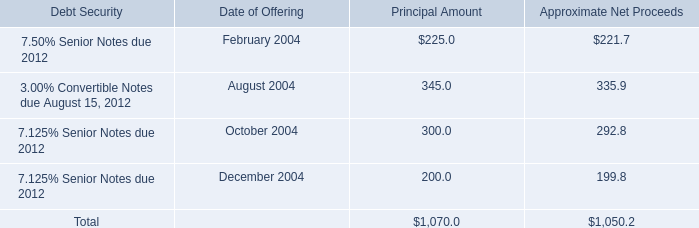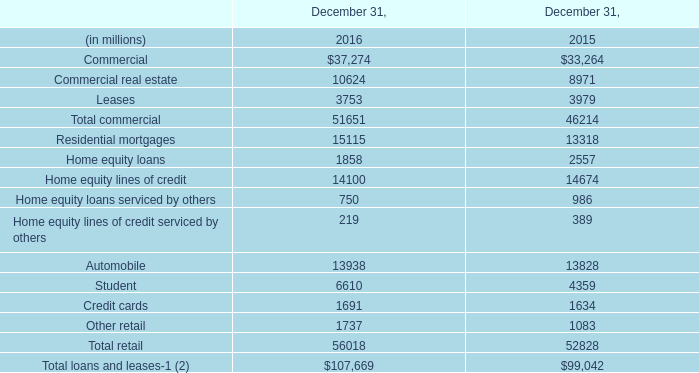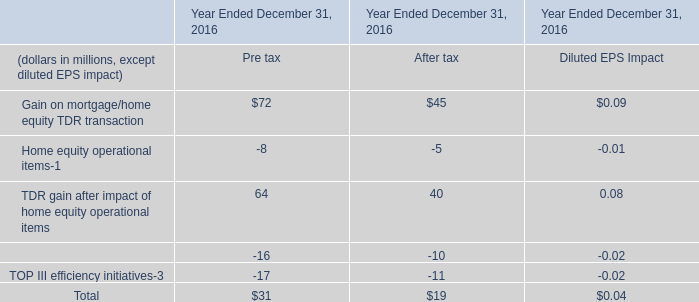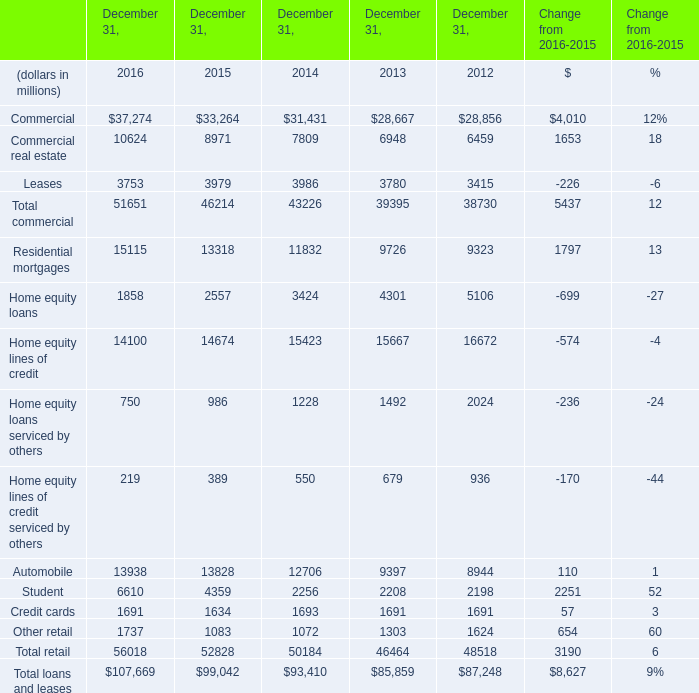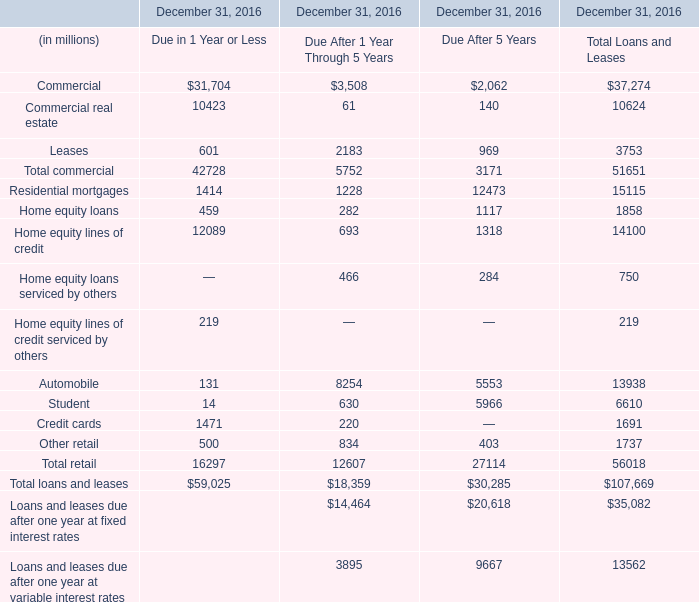If Commercial develops with the same growth rate in 2016, what will it reach in 2017? (in million) 
Computations: ((((37274 - 33264) / 37274) * 37274) + 37274)
Answer: 41284.0. 